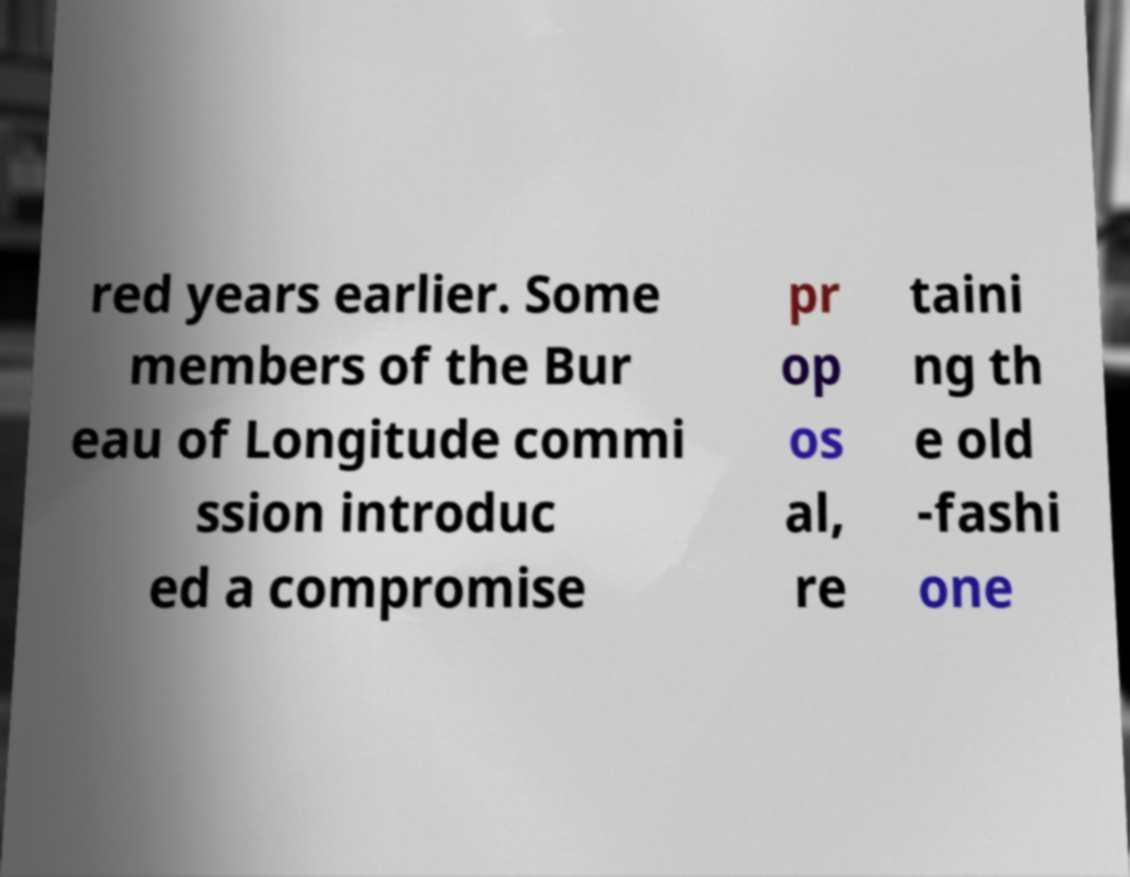For documentation purposes, I need the text within this image transcribed. Could you provide that? red years earlier. Some members of the Bur eau of Longitude commi ssion introduc ed a compromise pr op os al, re taini ng th e old -fashi one 